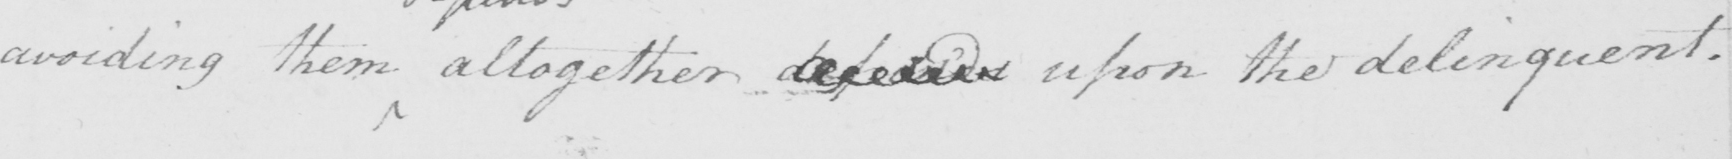Can you tell me what this handwritten text says? avoiding them altogether depends upon the deliquent . 